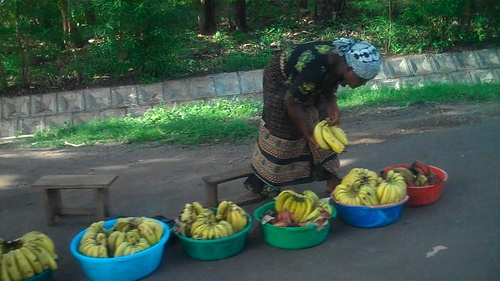Describe the objects in this image and their specific colors. I can see people in black, gray, and teal tones, bowl in black, olive, teal, and lightblue tones, banana in black and olive tones, banana in black, olive, and khaki tones, and bowl in black, teal, darkgreen, and gray tones in this image. 